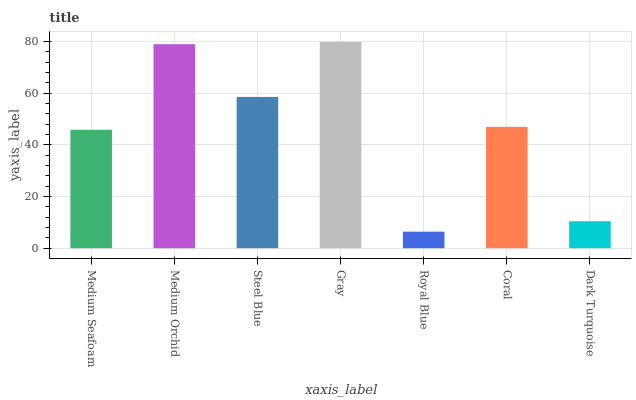Is Royal Blue the minimum?
Answer yes or no. Yes. Is Gray the maximum?
Answer yes or no. Yes. Is Medium Orchid the minimum?
Answer yes or no. No. Is Medium Orchid the maximum?
Answer yes or no. No. Is Medium Orchid greater than Medium Seafoam?
Answer yes or no. Yes. Is Medium Seafoam less than Medium Orchid?
Answer yes or no. Yes. Is Medium Seafoam greater than Medium Orchid?
Answer yes or no. No. Is Medium Orchid less than Medium Seafoam?
Answer yes or no. No. Is Coral the high median?
Answer yes or no. Yes. Is Coral the low median?
Answer yes or no. Yes. Is Steel Blue the high median?
Answer yes or no. No. Is Steel Blue the low median?
Answer yes or no. No. 